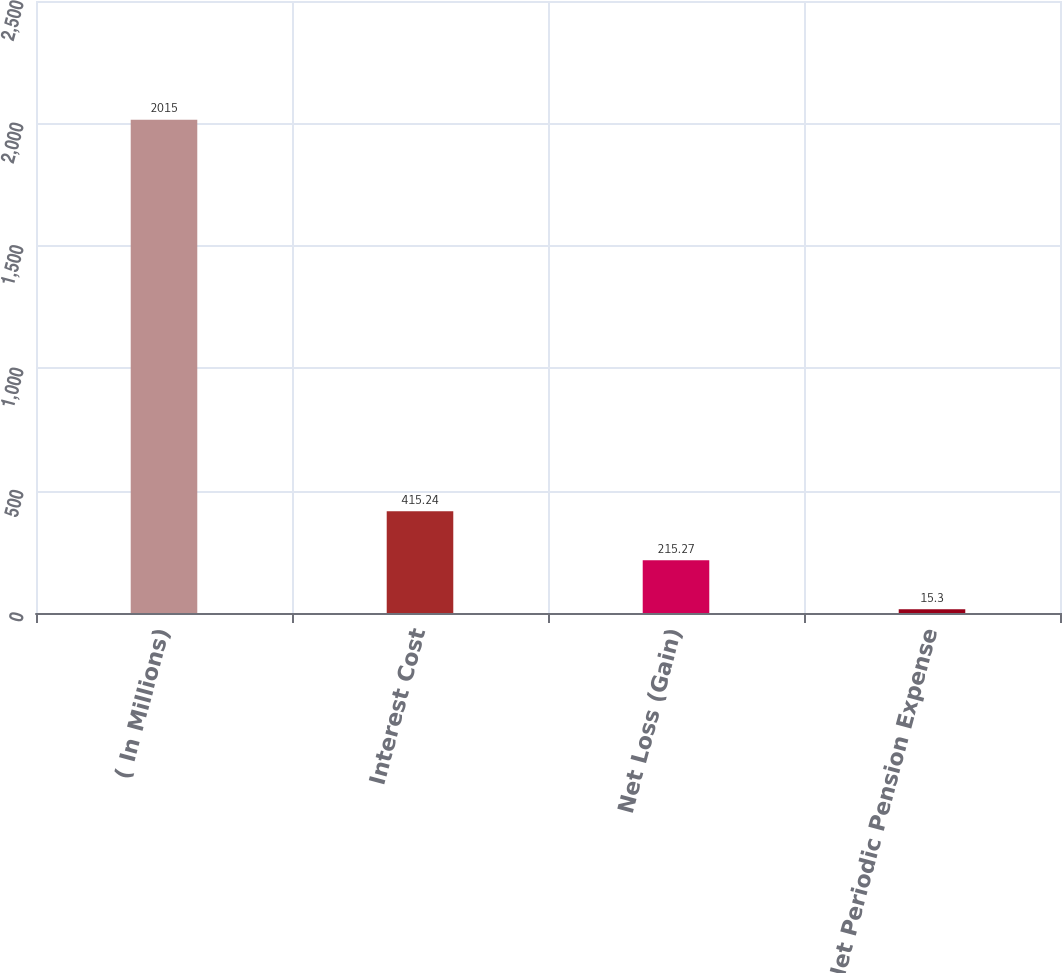Convert chart to OTSL. <chart><loc_0><loc_0><loc_500><loc_500><bar_chart><fcel>( In Millions)<fcel>Interest Cost<fcel>Net Loss (Gain)<fcel>Net Periodic Pension Expense<nl><fcel>2015<fcel>415.24<fcel>215.27<fcel>15.3<nl></chart> 